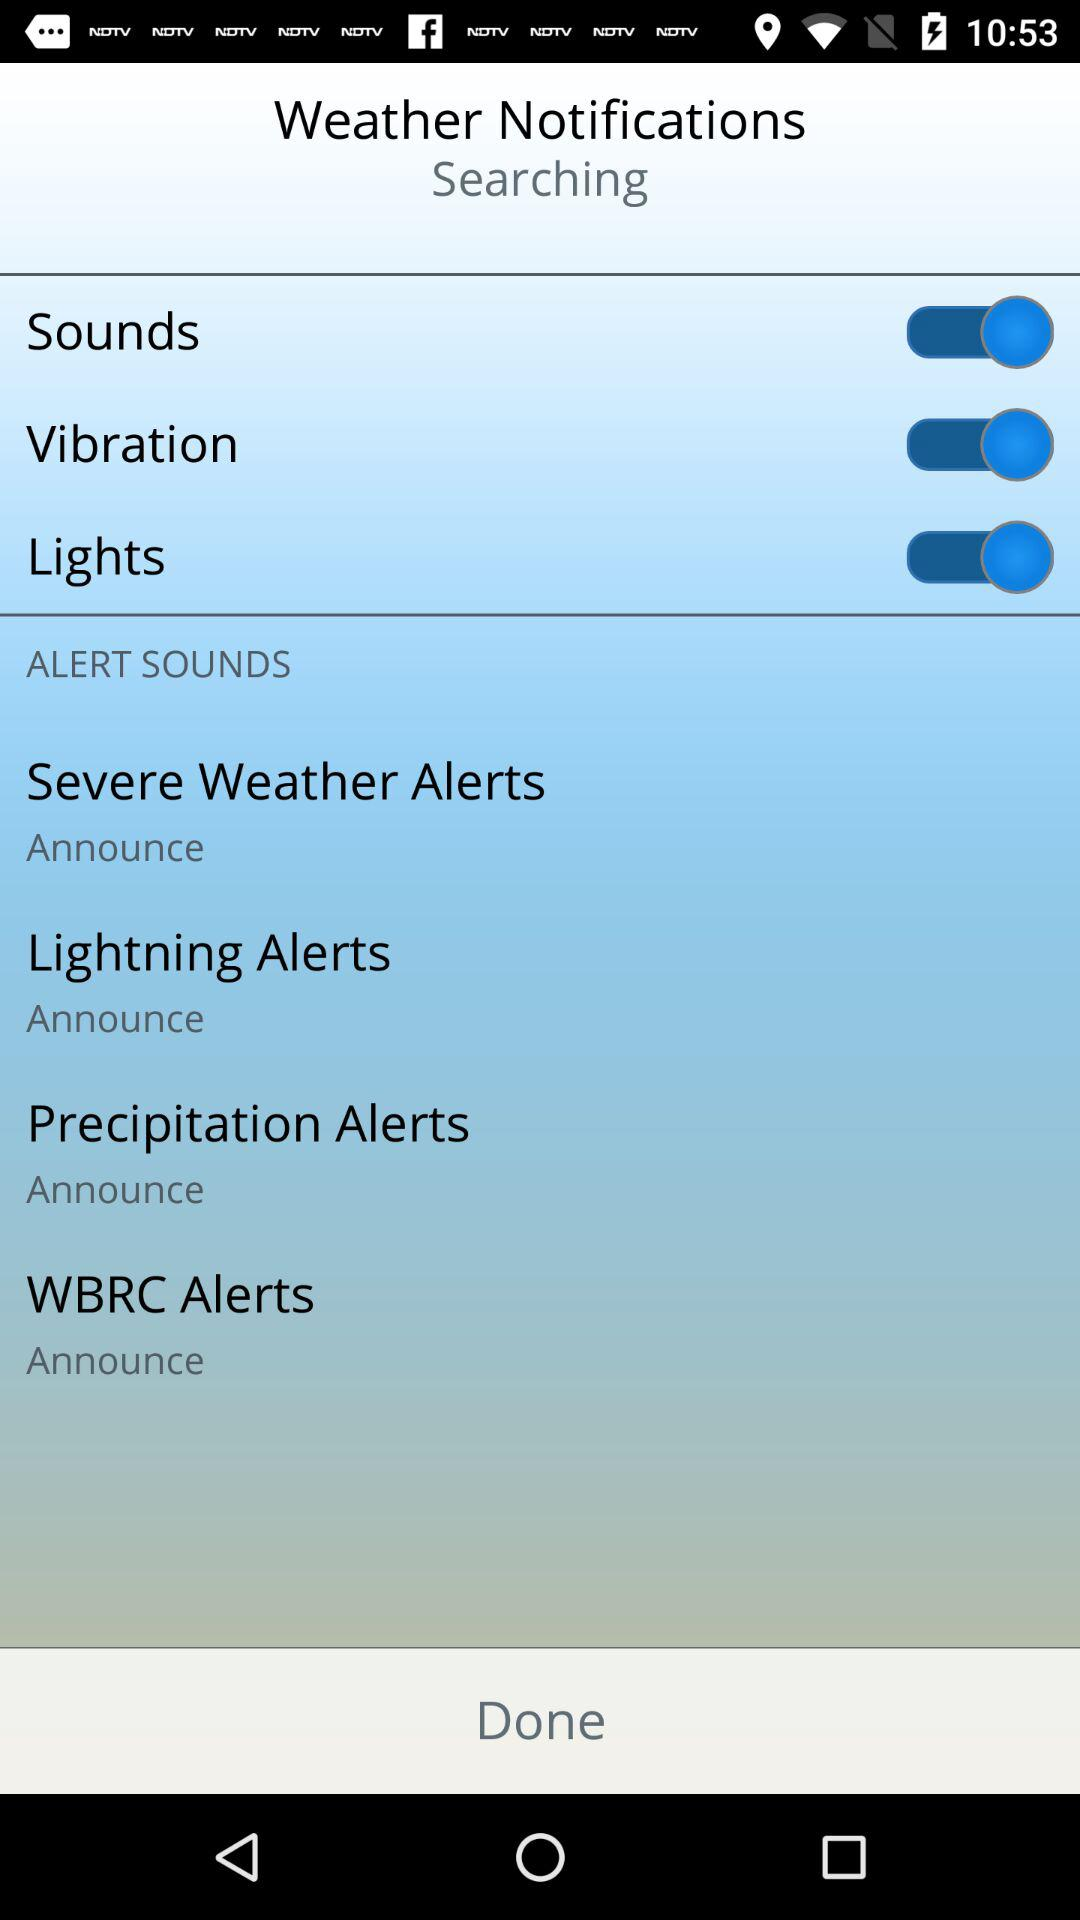What are the settings of alert sounds? The settings are "Severe Weather Alerts", "Lightning Alerts", "Precipitation Alerts" and "WBRC Alerts". 